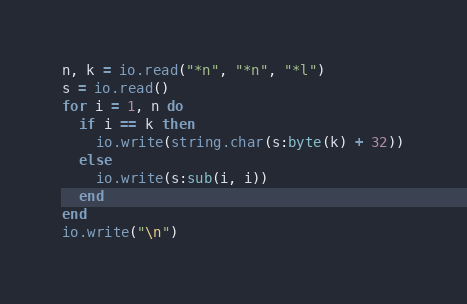Convert code to text. <code><loc_0><loc_0><loc_500><loc_500><_Lua_>n, k = io.read("*n", "*n", "*l")
s = io.read()
for i = 1, n do
  if i == k then
    io.write(string.char(s:byte(k) + 32))
  else
    io.write(s:sub(i, i))
  end
end
io.write("\n")
</code> 